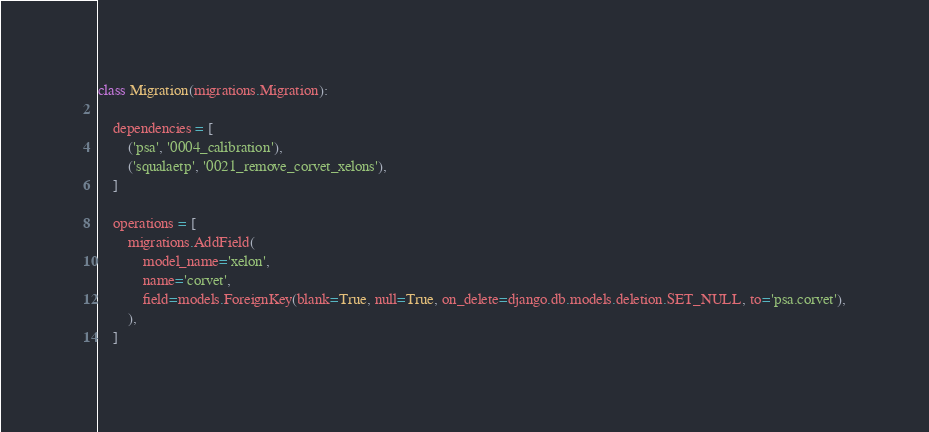Convert code to text. <code><loc_0><loc_0><loc_500><loc_500><_Python_>
class Migration(migrations.Migration):

    dependencies = [
        ('psa', '0004_calibration'),
        ('squalaetp', '0021_remove_corvet_xelons'),
    ]

    operations = [
        migrations.AddField(
            model_name='xelon',
            name='corvet',
            field=models.ForeignKey(blank=True, null=True, on_delete=django.db.models.deletion.SET_NULL, to='psa.corvet'),
        ),
    ]
</code> 